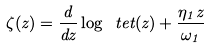<formula> <loc_0><loc_0><loc_500><loc_500>\zeta ( z ) = \frac { d } { d z } \log \ t e t ( z ) + \frac { \eta _ { 1 } z } { \omega _ { 1 } }</formula> 